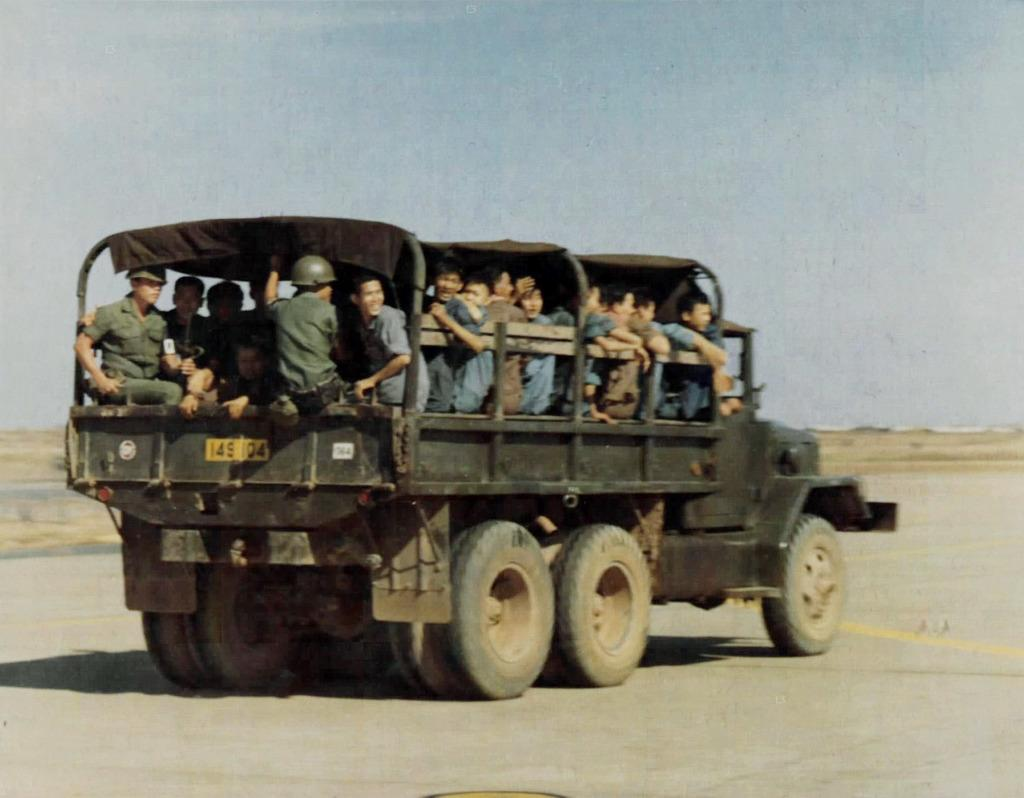What is happening in the image? There is a group of people sitting in a truck in the image. Where is the truck located? The truck is on the road. What can be seen in the background of the image? The sky is visible in the image. How would you describe the weather based on the sky? The sky looks cloudy in the image. What type of tool is the robin using to fix the carpenter's foot in the image? There is no robin, carpenter, or foot present in the image. 